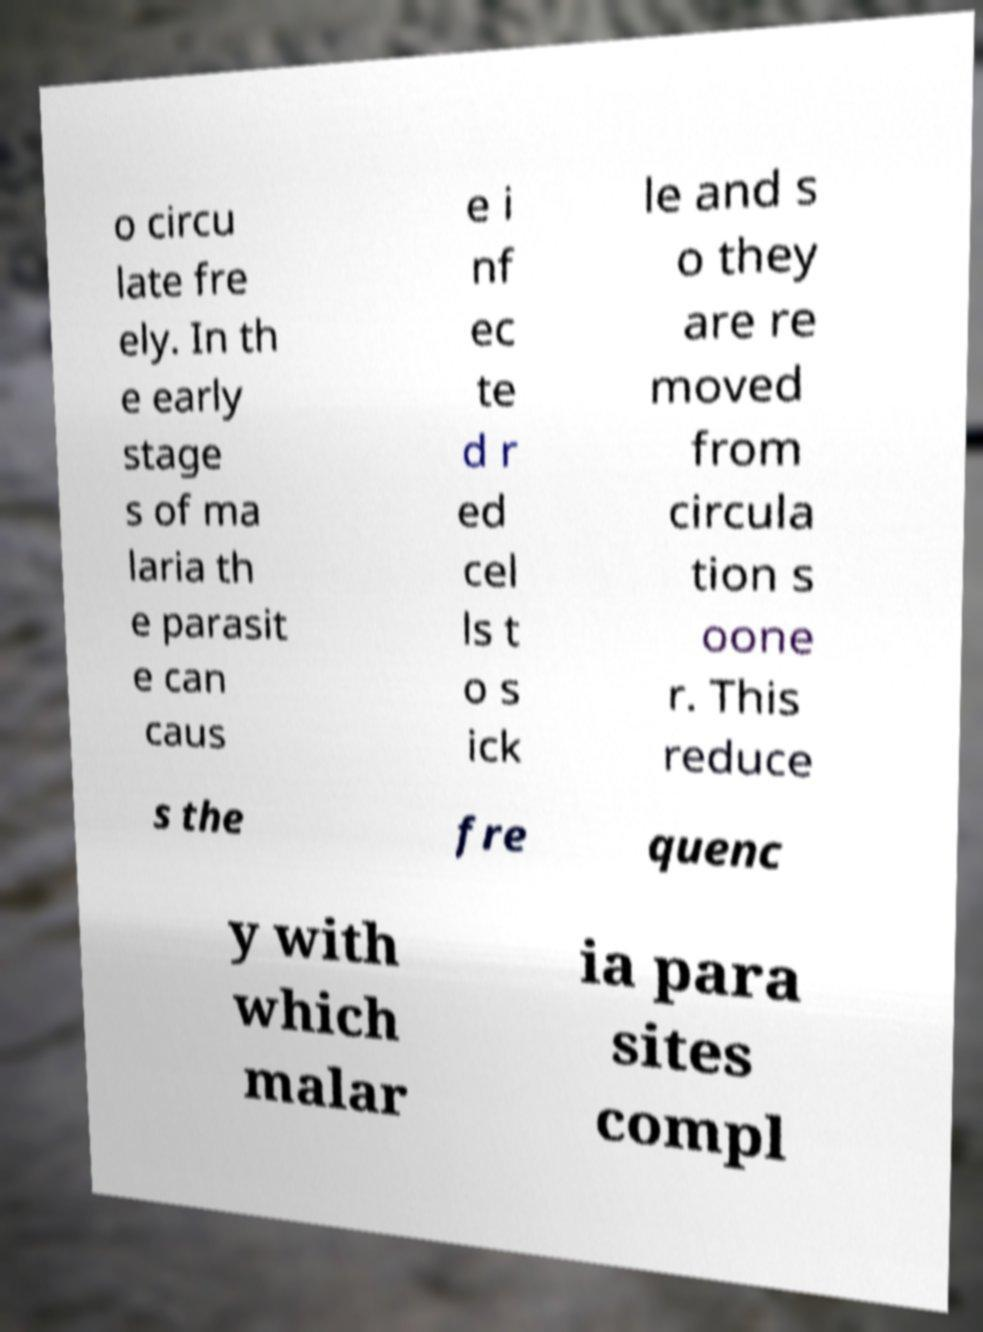Please read and relay the text visible in this image. What does it say? o circu late fre ely. In th e early stage s of ma laria th e parasit e can caus e i nf ec te d r ed cel ls t o s ick le and s o they are re moved from circula tion s oone r. This reduce s the fre quenc y with which malar ia para sites compl 